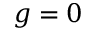<formula> <loc_0><loc_0><loc_500><loc_500>g = 0</formula> 